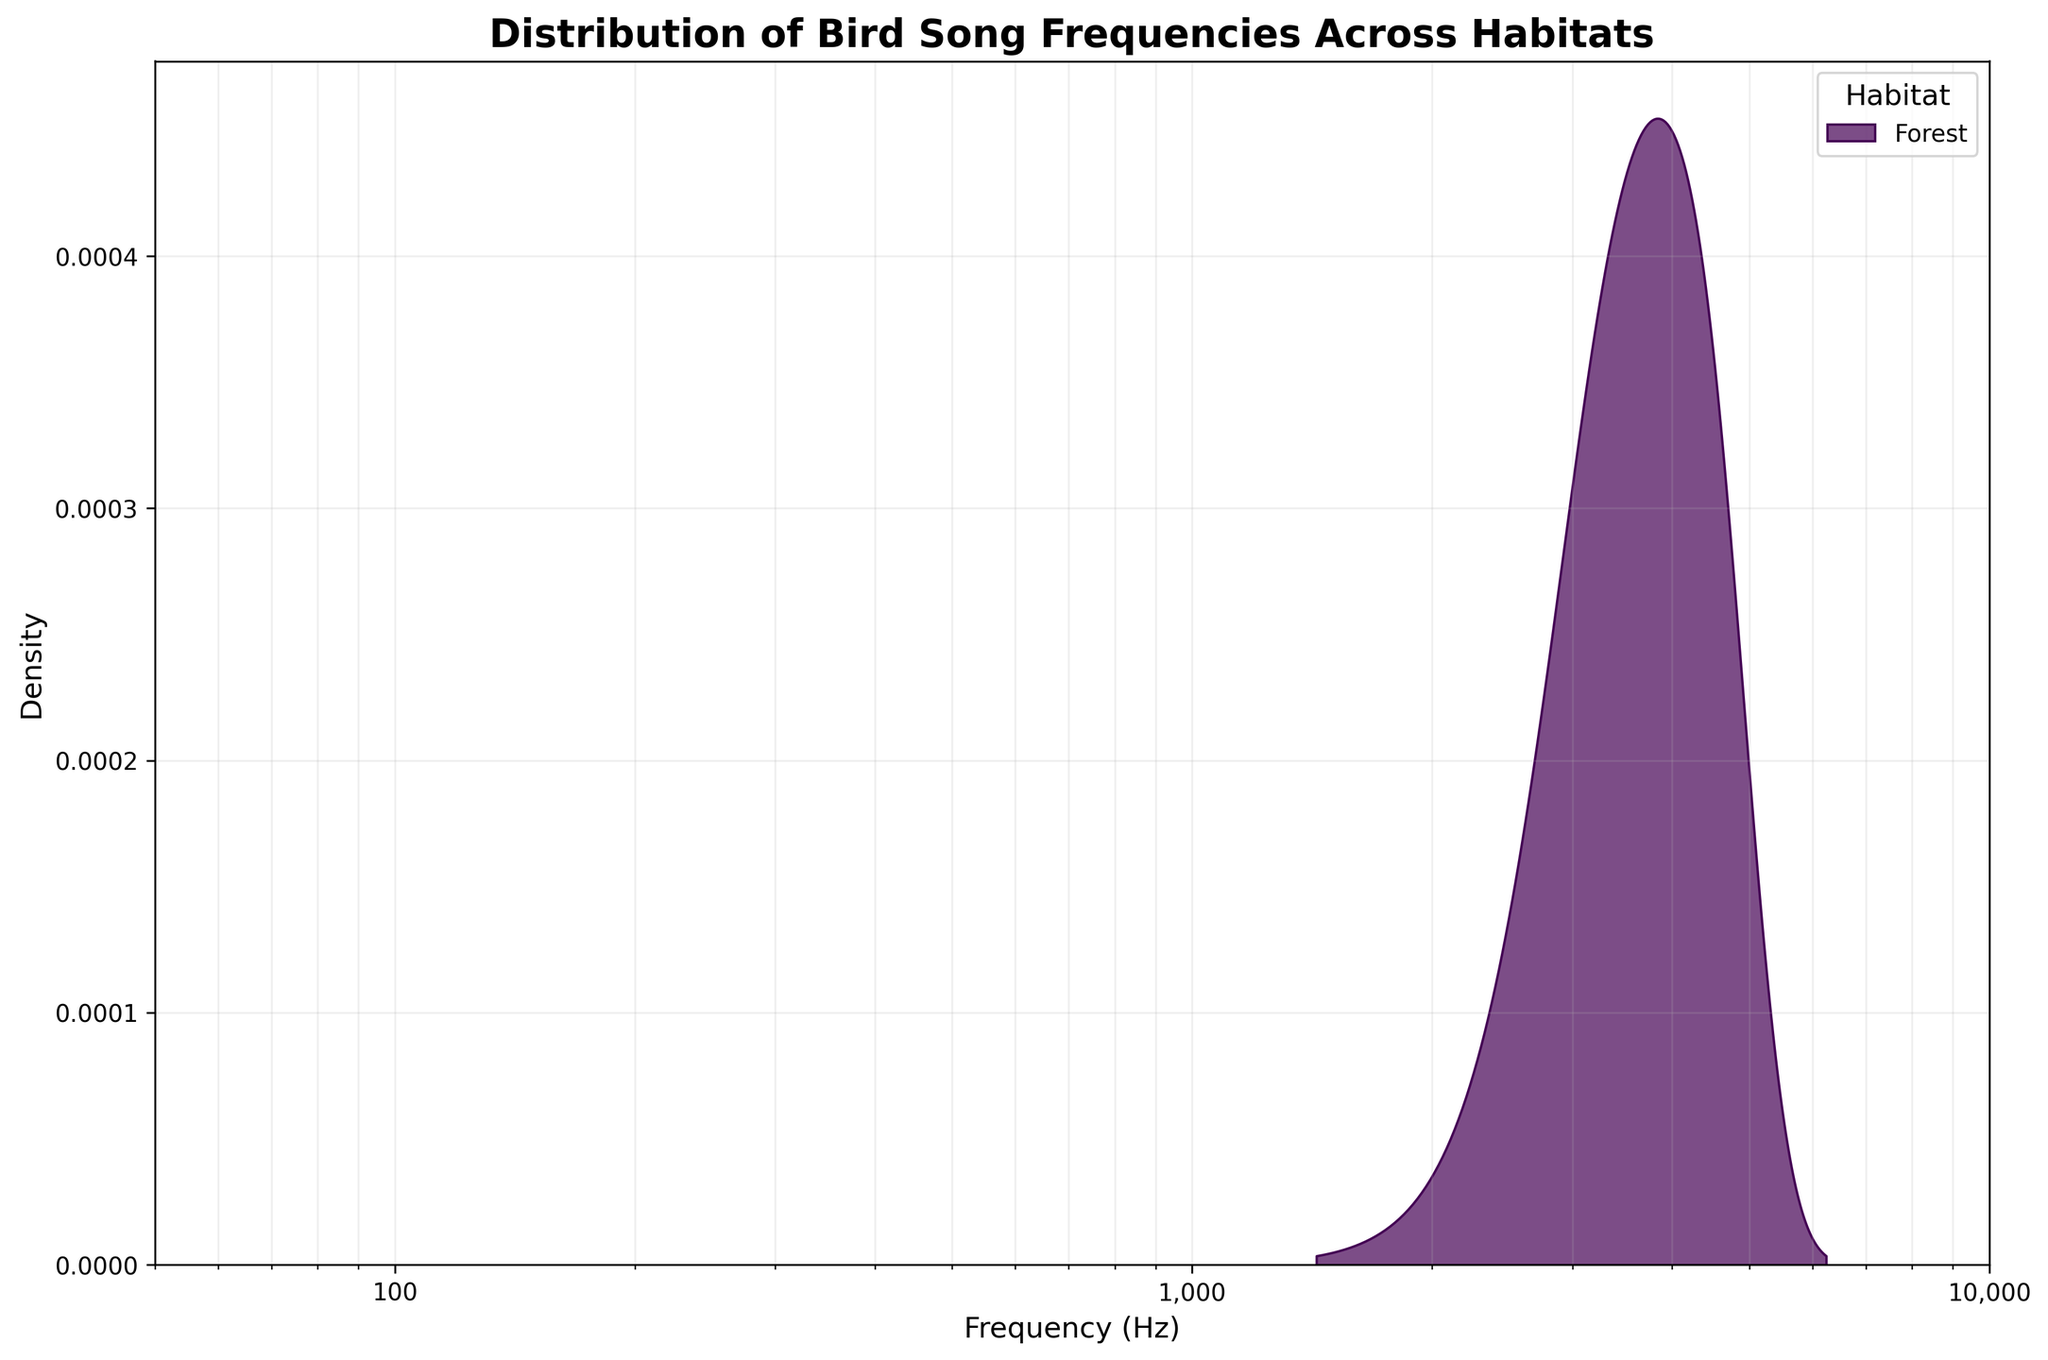What is the title of the figure? The title of the figure is usually located at the top and is the most prominent text element. In this case, it reads: "Distribution of Bird Song Frequencies Across Habitats".
Answer: Distribution of Bird Song Frequencies Across Habitats What is represented on the x-axis? The x-axis represents the frequency in Hertz (Hz) of the bird songs. This can be inferred from the labels and the context provided by the figure’s title.
Answer: Frequency (Hz) What does the shading under each curve represent? The shading under each curve represents the density distribution of bird song frequencies for different habitats. This is a common feature in density plots, where shading indicates areas of higher density.
Answer: Density distribution How many different habitats are represented in the plot? The legend indicates the number of different habitats, each represented by a different colored curve. Counting them provides the total number of habitats.
Answer: 9 Which habitat has the highest peak density? By visually comparing the curves, the habitat with the tallest peak (highest density) can be identified as having the highest peak density.
Answer: Forest What's the range of frequencies covered by the plot? The x-axis scale shows the minimum and maximum frequency values covered by the plot, which ranges from 50 Hz to 10,000 Hz.
Answer: 50 Hz to 10,000 Hz Which habitat has the lowest frequency bird songs? By identifying the curve that peaks at the lowest frequency on the x-axis, the habitat with the lowest frequency bird songs can be determined.
Answer: Wetland Which two habitats have the most similar frequency distributions? To find the two habitats with the most similar distributions, compare the shapes and positions of all the curves. The two curves that overlap the most or have very similar peaks and spreads are the most similar.
Answer: Forest and Urban How does the frequency distribution of bird songs in the coastal habitat compare to the desert habitat? Comparing the coastal and desert curves on the plot shows how their peaks and spreads align, revealing similarities and differences in their frequency distributions.
Answer: The coastal habitat has a broader peak at lower frequencies, while the desert habitat’s peak is at a higher frequency and less broad What is the purpose of using a logarithmic scale on the x-axis? The use of a logarithmic scale on the x-axis, indicated by the labels such as 100, 1,000, and 10,000, helps to better visualize and compare distributions across a wide range of frequencies by compressing the scale.
Answer: Better visualization across wide frequency range 